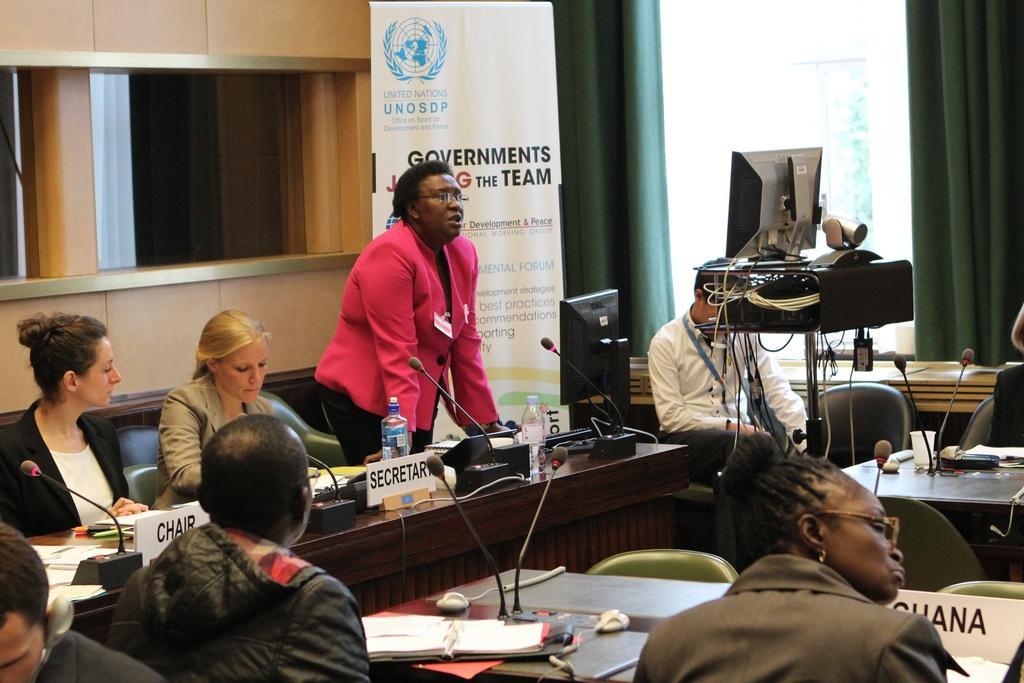Could you give a brief overview of what you see in this image? In this image there are people sitting on chairs, in front of them there are tables, on that tables there are few objects and a woman is standing, in the background there is a wall and a banner, on that banner there is some text and there are curtains in the center there is a stand, on that stand there is a monitor. 